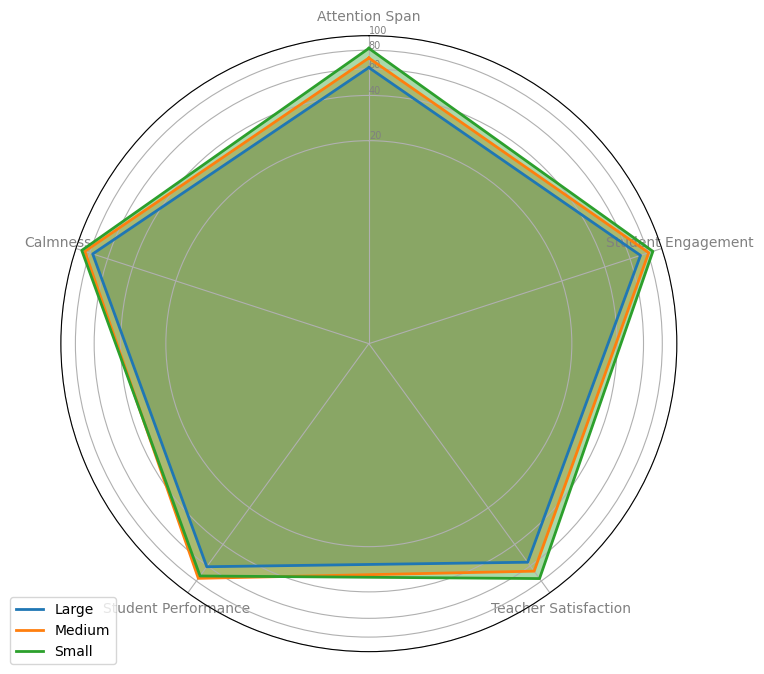What Classroom Size scores the highest in Calmness? By looking at the figure, you can see that 'Small' has the highest value for Calmness, since its data point is the farthest from the origin compared to 'Medium' and 'Large'.
Answer: Small How does Student Performance in Medium classrooms compare to Large classrooms? In the figure, 'Medium' classrooms have a higher Student Performance value than 'Large' classrooms. The data point for 'Medium' in Student Performance is farther from the origin than that for 'Large'.
Answer: Medium is higher Which Classroom Size shows the least effective Attention Span enhancement? By examining the location of the point for Attention Span, 'Large' classrooms have the lowest value because its point is closest to the origin among all Classroom Sizes.
Answer: Large What is the difference in Teacher Satisfaction between Small and Medium Classroom Sizes? To find the difference, observe the Teacher Satisfaction data points in the figure. 'Small' is closer to the outer ring and 'Medium' is closer to the middle. The difference is the vertical distance between these points. Calculate the actual percentage scores and subtract: 76.33 (Small) - 66.33 (Medium) = 10.
Answer: 10 Which Classroom Size is most effective in enhancing Student Engagement? In the figure, look at the Student Engagement data points and observe which one is the farthest from the origin. 'Small' classrooms have the highest score for Student Engagement.
Answer: Small What's the average Student Engagement across all Classroom Sizes? To find the average, calculate the mean of the Student Engagement scores for 'Small', 'Medium', and 'Large'. (Average for 'Small' = 86.66, 'Medium' = 81, 'Large' = 71.33). The overall mean is (86.66 + 81 + 71.33) / 3 = 79.
Answer: 79 Are Student Performance and Teacher Satisfaction positively correlated in any Classroom Size? Observing the radar chart, we need to check if higher Student Performance values correspond to higher Teacher Satisfaction values. In 'Small' and 'Medium' classrooms, higher Student Performance coincides with higher Teacher Satisfaction.
Answer: Yes, in Small and Medium Compare the Calmness scores between Small and Large Classroom Sizes. Which one is higher, and by how much? From the chart, Small classrooms have a higher Calmness value than Large classrooms. To find the difference, calculate the actual percentages: 91 (Small) - 76.33 (Large) = 14.67.
Answer: Small is higher by 14.67 What is the combined average score for Teacher Satisfaction and Student Performance in Medium-sized classrooms? Calculate the average for the two metrics for Medium classrooms. Teacher Satisfaction: 66.33, Student Performance: 76. Calculate the combined average: (66.33 + 76) / 2 = 71.17.
Answer: 71.17 